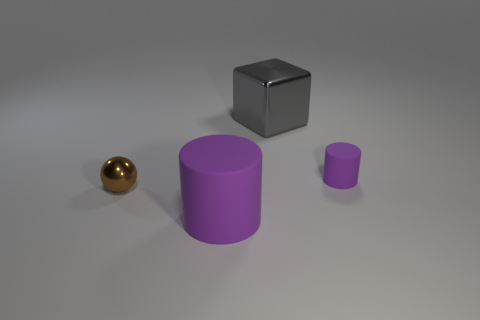The other matte thing that is the same shape as the large purple rubber object is what color?
Provide a succinct answer. Purple. There is a shiny object that is on the left side of the purple thing in front of the shiny object that is to the left of the large gray metal cube; what shape is it?
Your answer should be very brief. Sphere. The gray cube has what size?
Provide a succinct answer. Large. There is a big gray thing that is the same material as the tiny ball; what shape is it?
Make the answer very short. Cube. Is the number of big purple matte objects behind the large gray cube less than the number of large gray matte cylinders?
Your answer should be compact. No. There is a matte cylinder behind the small brown object; what is its color?
Keep it short and to the point. Purple. Are there any small brown things of the same shape as the large purple thing?
Offer a very short reply. No. What number of other matte objects have the same shape as the big purple matte thing?
Offer a terse response. 1. Is the color of the big block the same as the metal ball?
Keep it short and to the point. No. Are there fewer small brown metal objects than tiny cyan shiny cylinders?
Make the answer very short. No. 